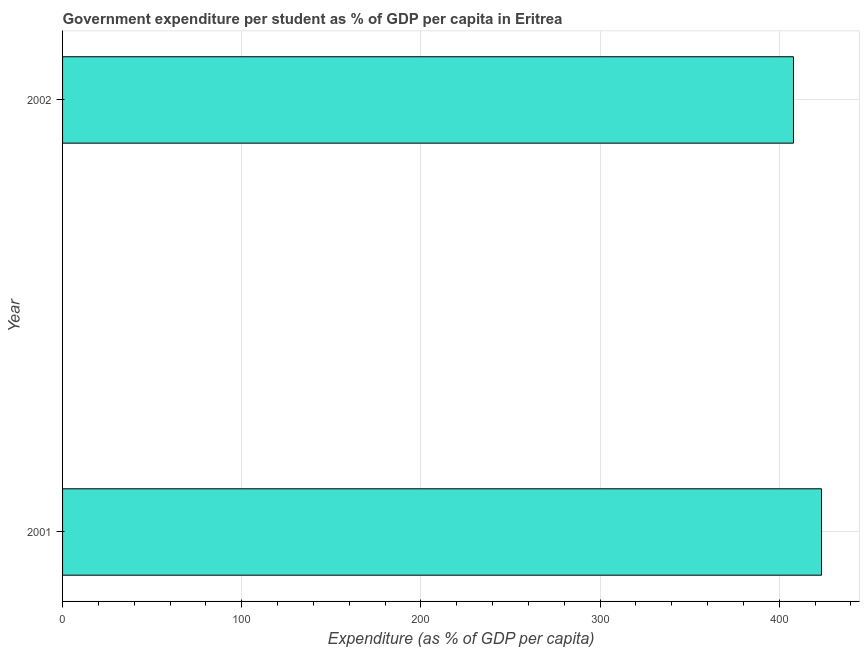Does the graph contain any zero values?
Keep it short and to the point. No. What is the title of the graph?
Your answer should be very brief. Government expenditure per student as % of GDP per capita in Eritrea. What is the label or title of the X-axis?
Give a very brief answer. Expenditure (as % of GDP per capita). What is the government expenditure per student in 2001?
Offer a very short reply. 423.59. Across all years, what is the maximum government expenditure per student?
Give a very brief answer. 423.59. Across all years, what is the minimum government expenditure per student?
Your answer should be compact. 407.92. What is the sum of the government expenditure per student?
Offer a very short reply. 831.51. What is the difference between the government expenditure per student in 2001 and 2002?
Ensure brevity in your answer.  15.67. What is the average government expenditure per student per year?
Provide a succinct answer. 415.76. What is the median government expenditure per student?
Provide a short and direct response. 415.76. What is the ratio of the government expenditure per student in 2001 to that in 2002?
Provide a succinct answer. 1.04. Is the government expenditure per student in 2001 less than that in 2002?
Your answer should be compact. No. Are all the bars in the graph horizontal?
Provide a succinct answer. Yes. How many years are there in the graph?
Keep it short and to the point. 2. What is the difference between two consecutive major ticks on the X-axis?
Provide a short and direct response. 100. Are the values on the major ticks of X-axis written in scientific E-notation?
Keep it short and to the point. No. What is the Expenditure (as % of GDP per capita) in 2001?
Make the answer very short. 423.59. What is the Expenditure (as % of GDP per capita) of 2002?
Your answer should be very brief. 407.92. What is the difference between the Expenditure (as % of GDP per capita) in 2001 and 2002?
Keep it short and to the point. 15.67. What is the ratio of the Expenditure (as % of GDP per capita) in 2001 to that in 2002?
Your response must be concise. 1.04. 